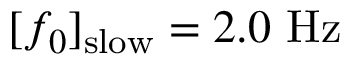<formula> <loc_0><loc_0><loc_500><loc_500>[ f _ { 0 } ] _ { s l o w } = 2 . 0 \ H z</formula> 